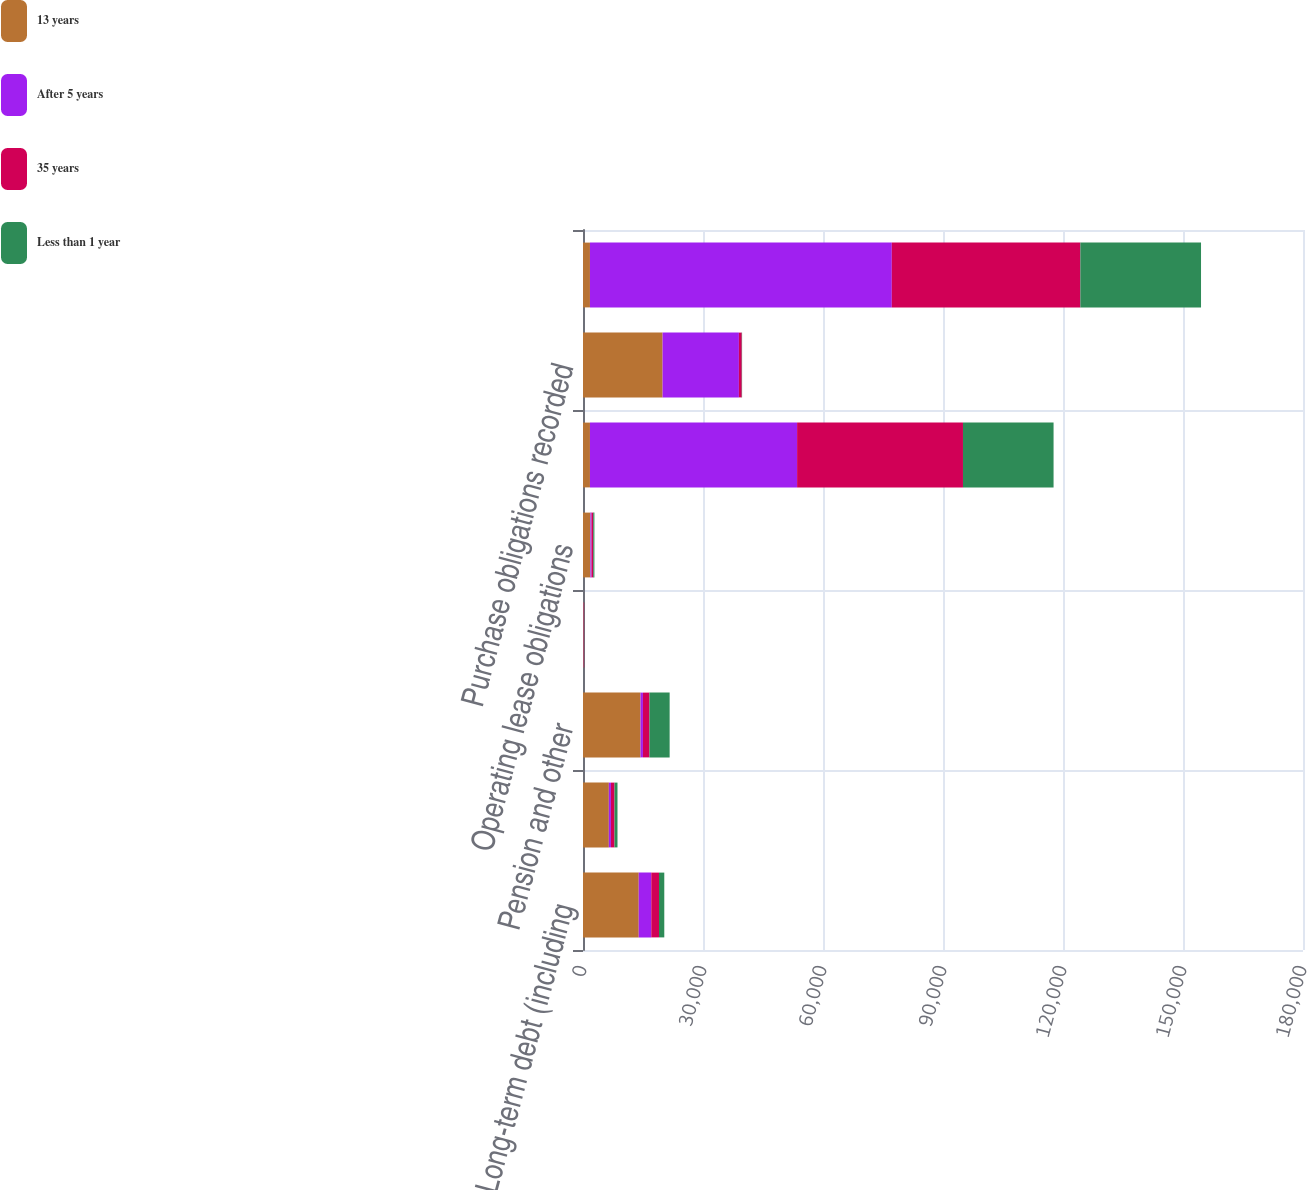Convert chart. <chart><loc_0><loc_0><loc_500><loc_500><stacked_bar_chart><ecel><fcel>Long-term debt (including<fcel>Interest on debt<fcel>Pension and other<fcel>Capital lease obligations<fcel>Operating lease obligations<fcel>Purchase obligations not<fcel>Purchase obligations recorded<fcel>Total contractual obligations<nl><fcel>13 years<fcel>13932<fcel>6458<fcel>14379<fcel>164<fcel>1850<fcel>1738.5<fcel>19900<fcel>1738.5<nl><fcel>After 5 years<fcel>3137<fcel>523<fcel>606<fcel>58<fcel>278<fcel>51784<fcel>19076<fcel>75462<nl><fcel>35 years<fcel>1927<fcel>891<fcel>1627<fcel>75<fcel>432<fcel>41470<fcel>716<fcel>47138<nl><fcel>Less than 1 year<fcel>1326<fcel>752<fcel>5050<fcel>20<fcel>291<fcel>22649<fcel>80<fcel>30168<nl></chart> 